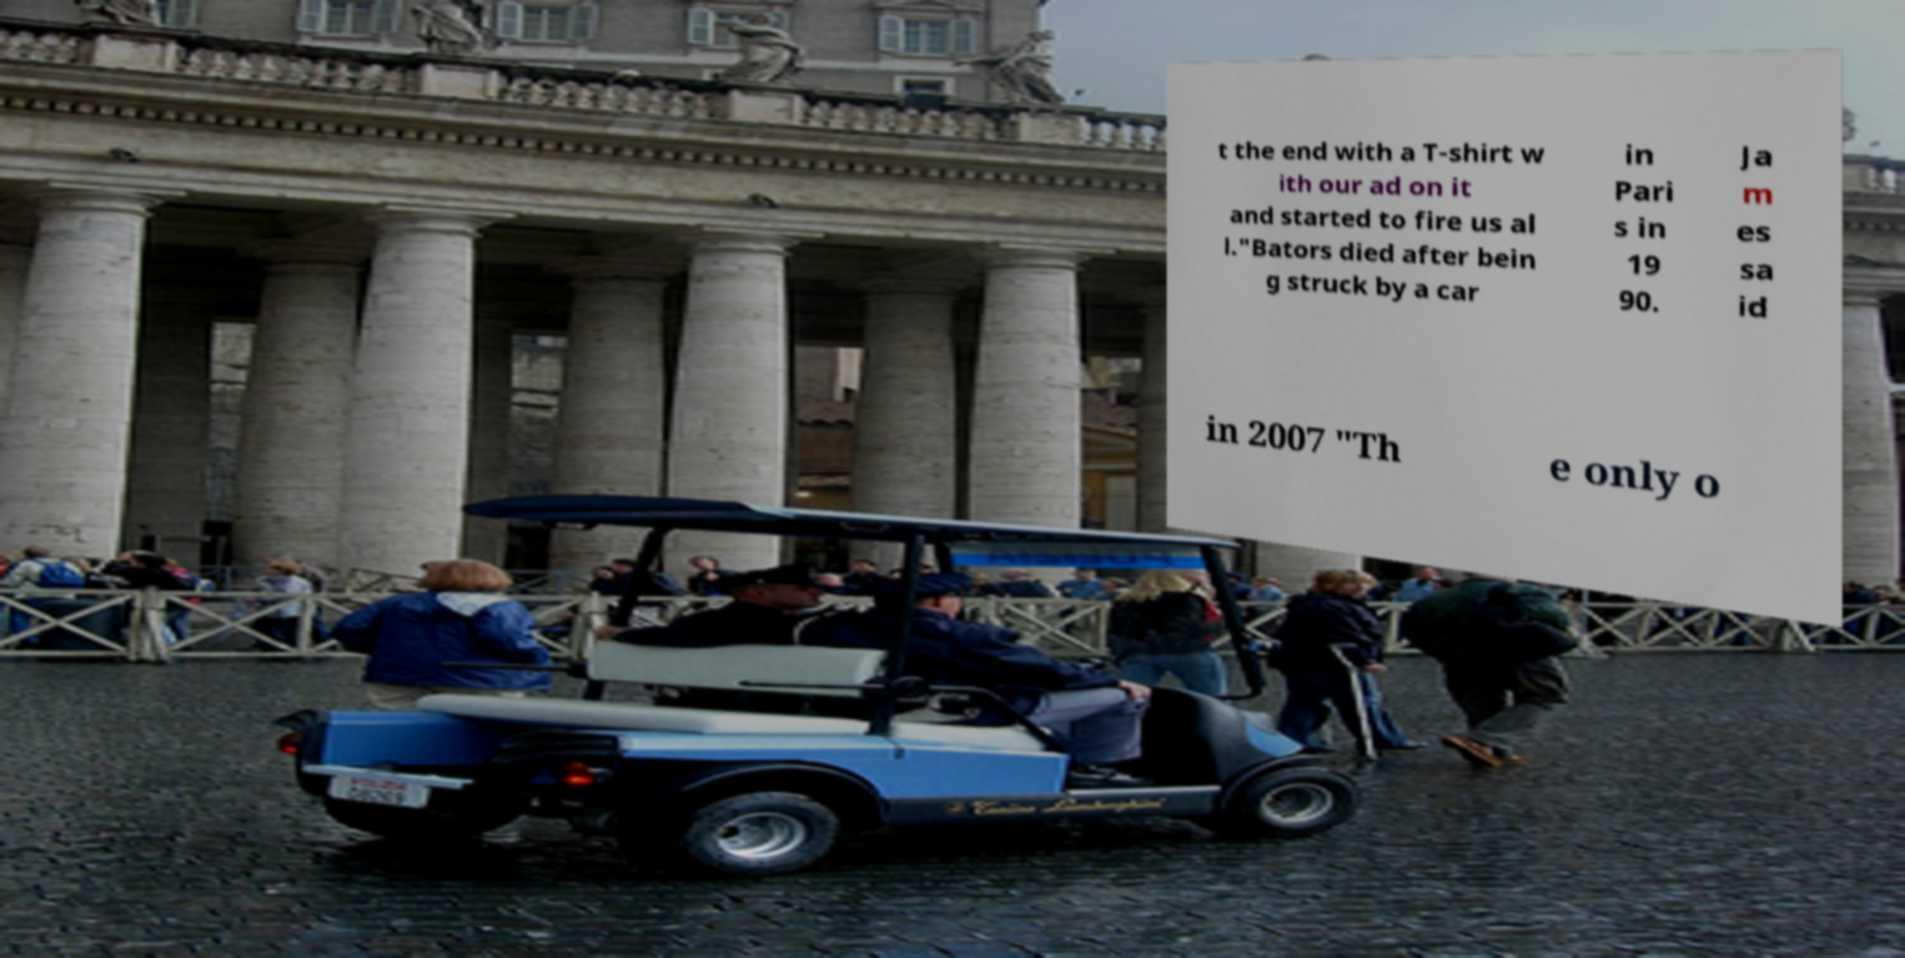There's text embedded in this image that I need extracted. Can you transcribe it verbatim? t the end with a T-shirt w ith our ad on it and started to fire us al l."Bators died after bein g struck by a car in Pari s in 19 90. Ja m es sa id in 2007 "Th e only o 